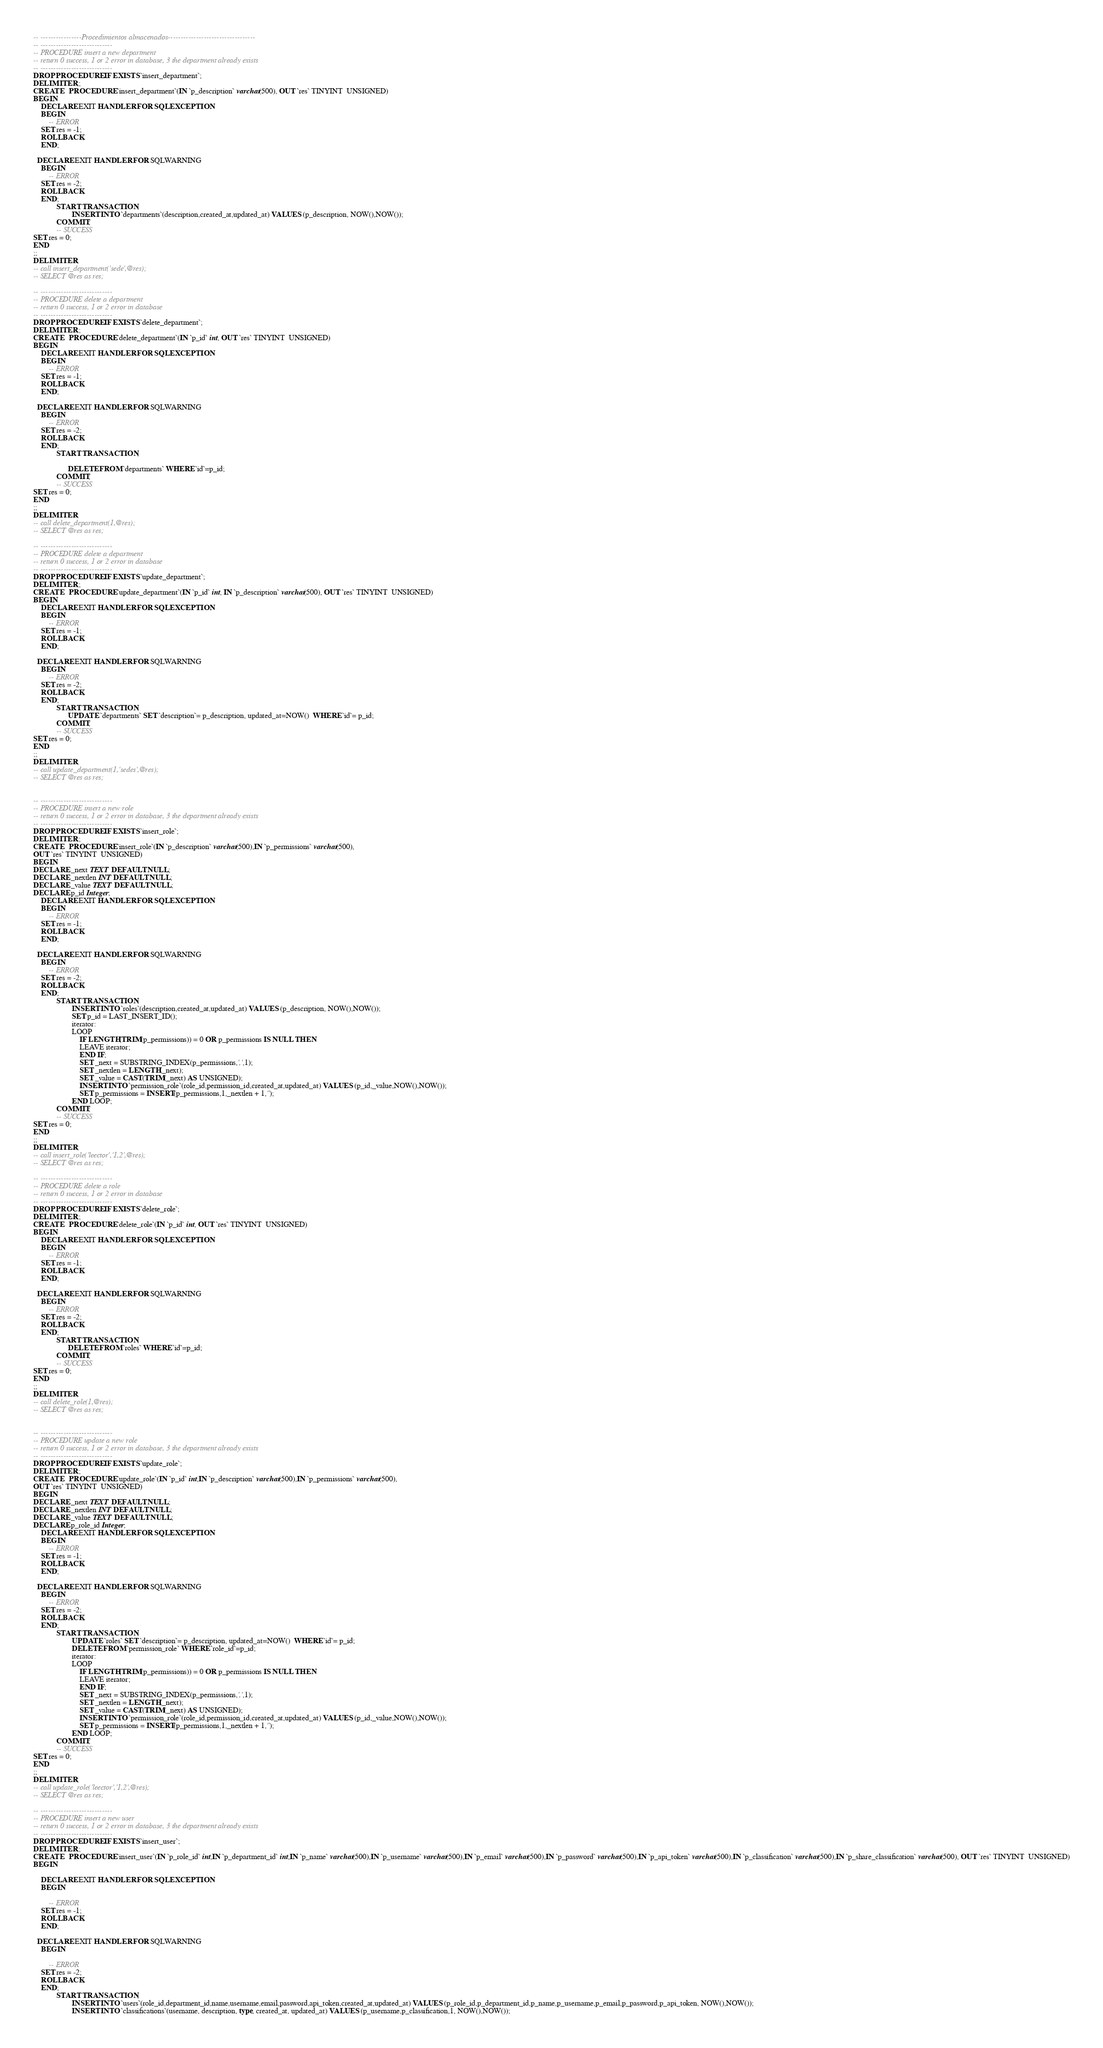<code> <loc_0><loc_0><loc_500><loc_500><_SQL_>-- ----------------Procedimientos almacenados----------------------------------
-- ----------------------------
-- PROCEDURE insert a new department
-- return 0 success, 1 or 2 error in database, 3 the department already exists
-- ----------------------------
DROP PROCEDURE IF EXISTS `insert_department`;
DELIMITER ;;
CREATE   PROCEDURE `insert_department`(IN `p_description` varchar(500), OUT `res` TINYINT  UNSIGNED)
BEGIN
	DECLARE EXIT HANDLER FOR SQLEXCEPTION
	BEGIN
		-- ERROR
    SET res = -1;
    ROLLBACK;
	END;

  DECLARE EXIT HANDLER FOR SQLWARNING
	BEGIN
		-- ERROR
    SET res = -2;
    ROLLBACK;
	END;
            START TRANSACTION;
                    INSERT INTO `departments`(description,created_at,updated_at) VALUES (p_description, NOW(),NOW());
            COMMIT;
            -- SUCCESS
SET res = 0;
END
;;
DELIMITER ;
-- call insert_department('sede',@res);
-- SELECT @res as res;

-- ----------------------------
-- PROCEDURE delete a department
-- return 0 success, 1 or 2 error in database
-- ----------------------------
DROP PROCEDURE IF EXISTS `delete_department`;
DELIMITER ;;
CREATE   PROCEDURE `delete_department`(IN `p_id` int, OUT `res` TINYINT  UNSIGNED)
BEGIN
	DECLARE EXIT HANDLER FOR SQLEXCEPTION
	BEGIN
		-- ERROR
    SET res = -1;
    ROLLBACK;
	END;

  DECLARE EXIT HANDLER FOR SQLWARNING
	BEGIN
		-- ERROR
    SET res = -2;
    ROLLBACK;
	END;
            START TRANSACTION;
                   
                  DELETE FROM `departments` WHERE `id`=p_id; 
            COMMIT;
            -- SUCCESS
SET res = 0;
END
;;
DELIMITER ;
-- call delete_department(1,@res);
-- SELECT @res as res;

-- ----------------------------
-- PROCEDURE delete a department
-- return 0 success, 1 or 2 error in database
-- ----------------------------
DROP PROCEDURE IF EXISTS `update_department`;
DELIMITER ;;
CREATE   PROCEDURE `update_department`(IN `p_id` int, IN `p_description` varchar(500), OUT `res` TINYINT  UNSIGNED)
BEGIN
	DECLARE EXIT HANDLER FOR SQLEXCEPTION
	BEGIN
		-- ERROR
    SET res = -1;
    ROLLBACK;
	END;

  DECLARE EXIT HANDLER FOR SQLWARNING
	BEGIN
		-- ERROR
    SET res = -2;
    ROLLBACK;
	END;
            START TRANSACTION;
                  UPDATE `departments` SET `description`= p_description, updated_at=NOW()  WHERE `id`= p_id; 
            COMMIT;
            -- SUCCESS
SET res = 0;
END
;;
DELIMITER ;
-- call update_department(1,'sedes',@res);
-- SELECT @res as res;


-- ----------------------------
-- PROCEDURE insert a new role
-- return 0 success, 1 or 2 error in database, 3 the department already exists
-- ----------------------------
DROP PROCEDURE IF EXISTS `insert_role`;
DELIMITER ;;
CREATE   PROCEDURE `insert_role`(IN `p_description` varchar(500),IN `p_permissions` varchar(500),
OUT `res` TINYINT  UNSIGNED)
BEGIN
DECLARE _next TEXT DEFAULT NULL;
DECLARE _nextlen INT DEFAULT NULL;
DECLARE _value TEXT DEFAULT NULL;
DECLARE p_id Integer;
	DECLARE EXIT HANDLER FOR SQLEXCEPTION
	BEGIN
		-- ERROR
    SET res = -1;
    ROLLBACK;
	END;

  DECLARE EXIT HANDLER FOR SQLWARNING
	BEGIN
		-- ERROR
    SET res = -2;
    ROLLBACK;
	END;
            START TRANSACTION;
                    INSERT INTO `roles`(description,created_at,updated_at) VALUES (p_description, NOW(),NOW());
                    SET p_id = LAST_INSERT_ID();
                    iterator:
                    LOOP
                        IF LENGTH(TRIM(p_permissions)) = 0 OR p_permissions IS NULL THEN
                        LEAVE iterator;
                        END IF;
                        SET _next = SUBSTRING_INDEX(p_permissions,',',1);
                        SET _nextlen = LENGTH(_next);
                        SET _value = CAST(TRIM(_next) AS UNSIGNED);
                        INSERT INTO `permission_role`(role_id,permission_id,created_at,updated_at) VALUES (p_id,_value,NOW(),NOW());
                        SET p_permissions = INSERT(p_permissions,1,_nextlen + 1,'');
                    END LOOP;
            COMMIT;
            -- SUCCESS
SET res = 0;
END
;;
DELIMITER ;
-- call insert_role('leector','1,2',@res);
-- SELECT @res as res;

-- ----------------------------
-- PROCEDURE delete a role
-- return 0 success, 1 or 2 error in database
-- ----------------------------
DROP PROCEDURE IF EXISTS `delete_role`;
DELIMITER ;;
CREATE   PROCEDURE `delete_role`(IN `p_id` int, OUT `res` TINYINT  UNSIGNED)
BEGIN
	DECLARE EXIT HANDLER FOR SQLEXCEPTION
	BEGIN
		-- ERROR
    SET res = -1;
    ROLLBACK;
	END;

  DECLARE EXIT HANDLER FOR SQLWARNING
	BEGIN
		-- ERROR
    SET res = -2;
    ROLLBACK;
	END;
            START TRANSACTION;                   
                  DELETE FROM `roles` WHERE `id`=p_id; 
            COMMIT;
            -- SUCCESS
SET res = 0;
END
;;
DELIMITER ;
-- call delete_role(1,@res);
-- SELECT @res as res;


-- ----------------------------
-- PROCEDURE update a new role
-- return 0 success, 1 or 2 error in database, 3 the department already exists
-- ----------------------------
DROP PROCEDURE IF EXISTS `update_role`;
DELIMITER ;;
CREATE   PROCEDURE `update_role`(IN `p_id` int,IN `p_description` varchar(500),IN `p_permissions` varchar(500),
OUT `res` TINYINT  UNSIGNED)
BEGIN
DECLARE _next TEXT DEFAULT NULL;
DECLARE _nextlen INT DEFAULT NULL;
DECLARE _value TEXT DEFAULT NULL;
DECLARE p_role_id Integer;
	DECLARE EXIT HANDLER FOR SQLEXCEPTION
	BEGIN
		-- ERROR
    SET res = -1;
    ROLLBACK;
	END;

  DECLARE EXIT HANDLER FOR SQLWARNING
	BEGIN
		-- ERROR
    SET res = -2;
    ROLLBACK;
	END;
            START TRANSACTION;
                    UPDATE `roles` SET `description`= p_description, updated_at=NOW()  WHERE `id`= p_id;
                    DELETE FROM `permission_role` WHERE `role_id`=p_id;
                    iterator:
                    LOOP
                        IF LENGTH(TRIM(p_permissions)) = 0 OR p_permissions IS NULL THEN
                        LEAVE iterator;
                        END IF;
                        SET _next = SUBSTRING_INDEX(p_permissions,',',1);
                        SET _nextlen = LENGTH(_next);
                        SET _value = CAST(TRIM(_next) AS UNSIGNED);
                        INSERT INTO `permission_role`(role_id,permission_id,created_at,updated_at) VALUES (p_id,_value,NOW(),NOW());
                        SET p_permissions = INSERT(p_permissions,1,_nextlen + 1,'');
                    END LOOP;
            COMMIT;
            -- SUCCESS
SET res = 0;
END
;;
DELIMITER ;
-- call update_role('leector','1,2',@res);
-- SELECT @res as res;

-- ----------------------------
-- PROCEDURE insert a new user
-- return 0 success, 1 or 2 error in database, 3 the department already exists
-- ----------------------------
DROP PROCEDURE IF EXISTS `insert_user`;
DELIMITER ;;
CREATE   PROCEDURE `insert_user`(IN `p_role_id` int,IN `p_department_id` int,IN `p_name` varchar(500),IN `p_username` varchar(500),IN `p_email` varchar(500),IN `p_password` varchar(500),IN `p_api_token` varchar(500),IN `p_classification` varchar(500),IN `p_share_classification` varchar(500), OUT `res` TINYINT  UNSIGNED)
BEGIN
 
	DECLARE EXIT HANDLER FOR SQLEXCEPTION
	BEGIN

		-- ERROR
    SET res = -1;
    ROLLBACK;
	END;

  DECLARE EXIT HANDLER FOR SQLWARNING
	BEGIN

		-- ERROR
    SET res = -2;
    ROLLBACK;
	END;
            START TRANSACTION;
                    INSERT INTO `users`(role_id,department_id,name,username,email,password,api_token,created_at,updated_at) VALUES (p_role_id,p_department_id,p_name,p_username,p_email,p_password,p_api_token, NOW(),NOW());
                    INSERT INTO `classifications`(username, description, type, created_at, updated_at) VALUES (p_username,p_classification,1, NOW(),NOW());</code> 